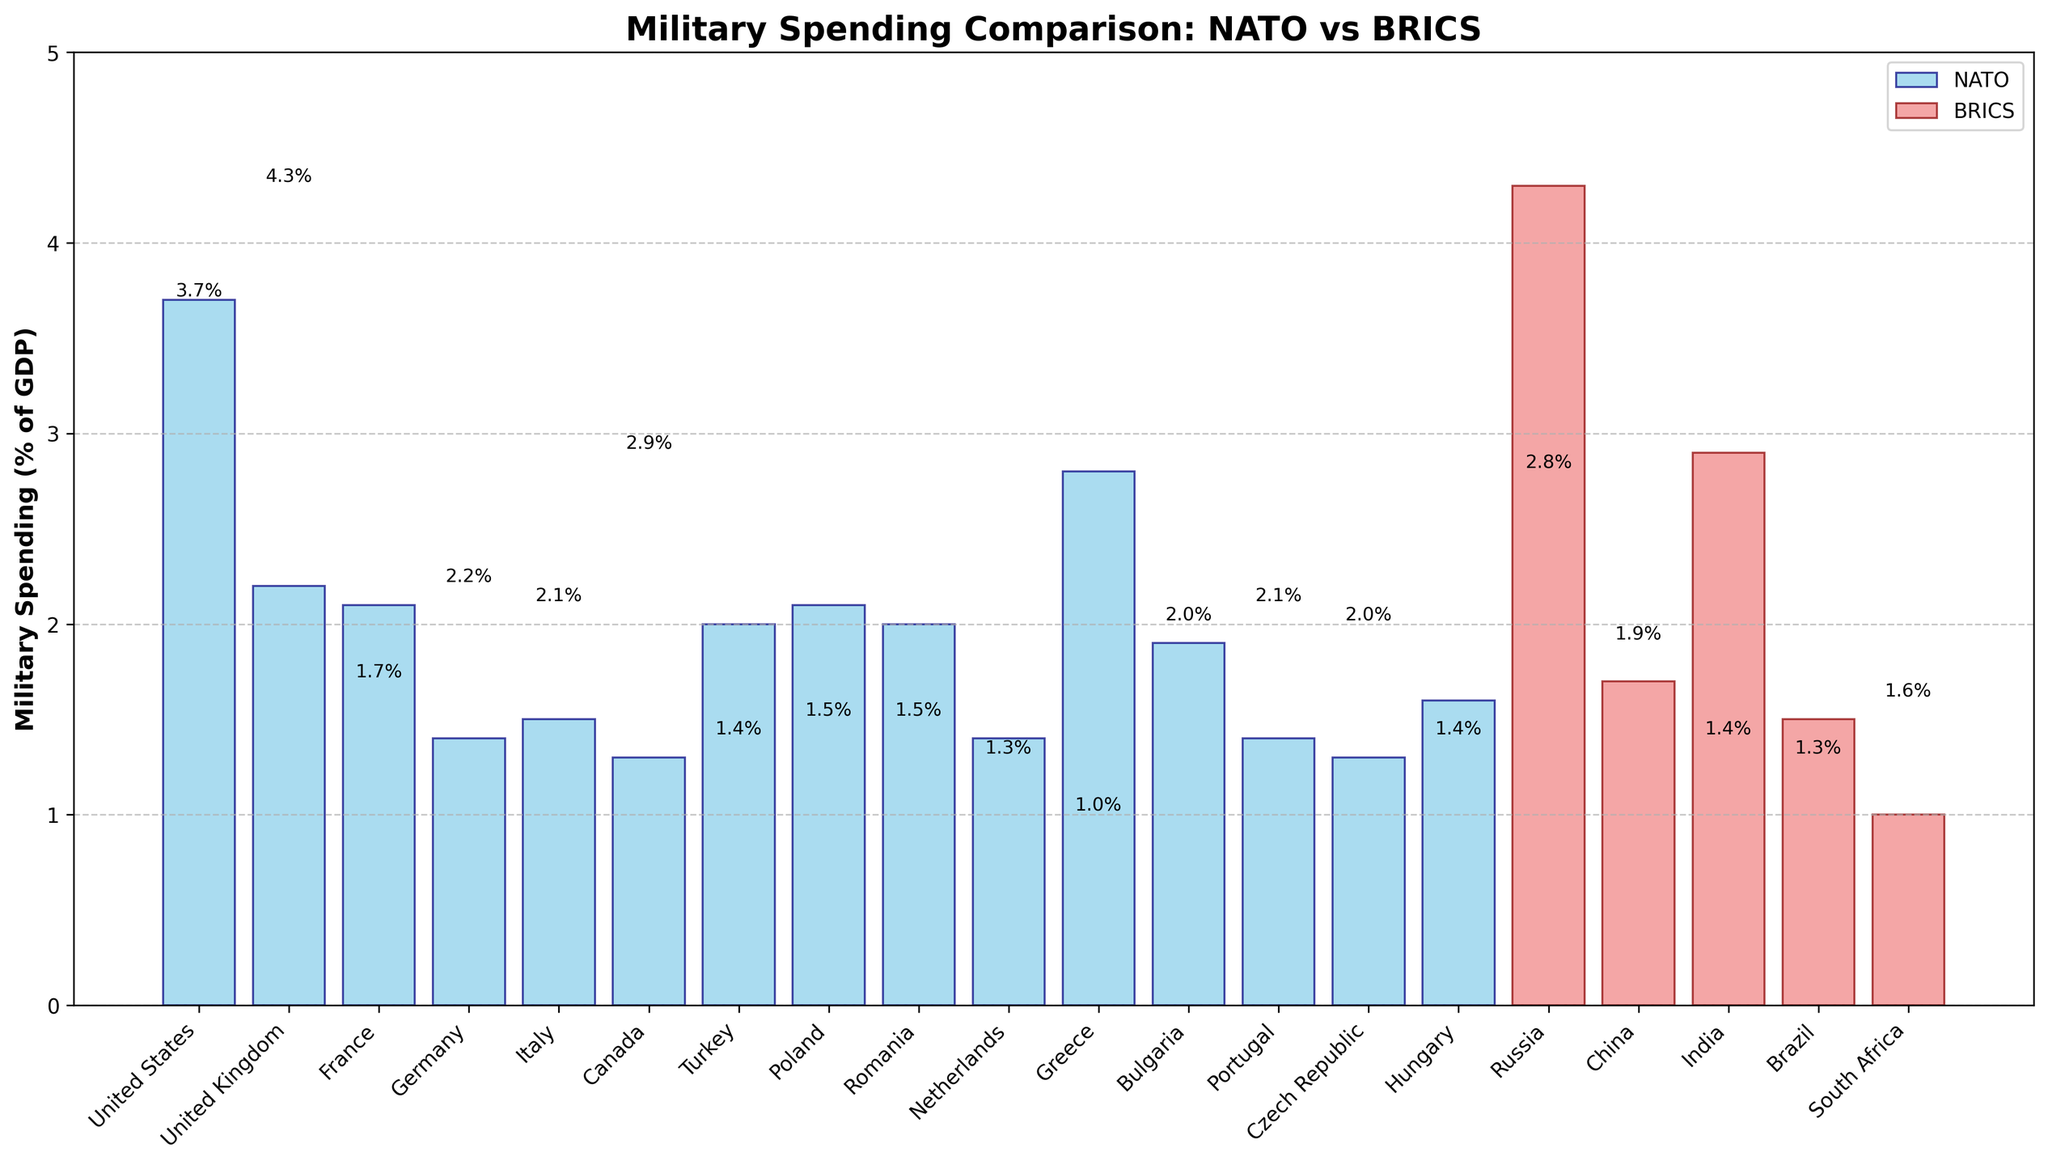Which country has the highest military spending as a percentage of GDP? By looking at the height of the bars and the values labeled on top of each, it becomes apparent that Russia has the highest military spending at 4.3%.
Answer: Russia How much more is the military spending of Russia compared to the United States? Russia has a military spending of 4.3%, and the United States has 3.7%. Subtracting these gives 4.3% - 3.7% = 0.6%.
Answer: 0.6% Which NATO country has the lowest military spending as a percentage of GDP? By looking at the heights of the blue bars, we can see that Canada has the lowest military spending at 1.3%.
Answer: Canada What is the average military spending of BRICS countries? Summing up the military spending percentages of BRICS countries – Russia (4.3%), China (1.7%), India (2.9%), Brazil (1.5%), South Africa (1.0%) – gives 4.3 + 1.7 + 2.9 + 1.5 + 1.0 = 11.4. Dividing this by the number of countries (5) gives 11.4 / 5 = 2.28%.
Answer: 2.28% How does the military spending of China compare to Germany? China has a military spending percentage of 1.7%, whereas Germany has 1.4%. This implies that China's spending is 0.3% higher than Germany's.
Answer: China spends 0.3% more Which group, NATO or BRICS has countries with higher variance in military spending? To determine the variance, note the spread in values within each group. NATO countries have a spread from 1.3% to 3.7%, whereas BRICS countries range from 1.0% to 4.3%. The variance in BRICS is higher because the range is wider.
Answer: BRICS Which NATO country has the highest military spending as a percentage of GDP? By inspecting the highest blue bar, the United States has the highest spending among NATO countries at 3.7%.
Answer: United States What is the sum of the military spending percentages for Italy and Canada? Italy has a military spending of 1.5% and Canada has 1.3%. Summing these gives 1.5% + 1.3% = 2.8%.
Answer: 2.8% Compare the military spending of Turkey to South Africa. Which is higher and by how much? Turkey has a military spending of 2.0%, and South Africa has 1.0%. Turkey's spending is 1.0% higher than South Africa.
Answer: Turkey by 1.0% 